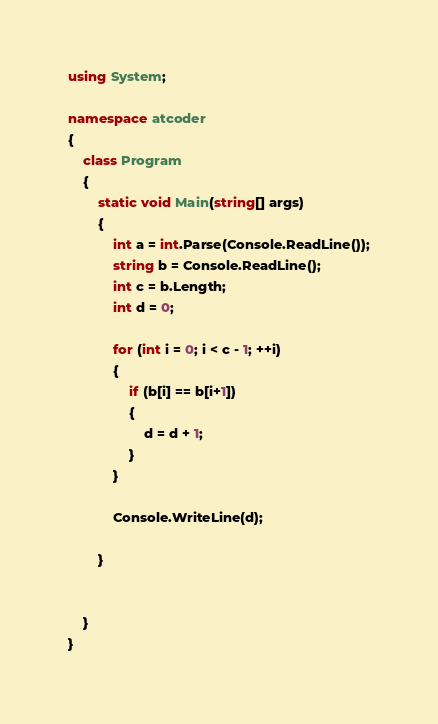<code> <loc_0><loc_0><loc_500><loc_500><_C#_>using System;

namespace atcoder
{
    class Program
    {
        static void Main(string[] args)
        {
            int a = int.Parse(Console.ReadLine());
            string b = Console.ReadLine();
            int c = b.Length;
            int d = 0;

            for (int i = 0; i < c - 1; ++i)
            {
                if (b[i] == b[i+1])
                {
                    d = d + 1;
                }
            }

            Console.WriteLine(d);

        }


    }
}
</code> 